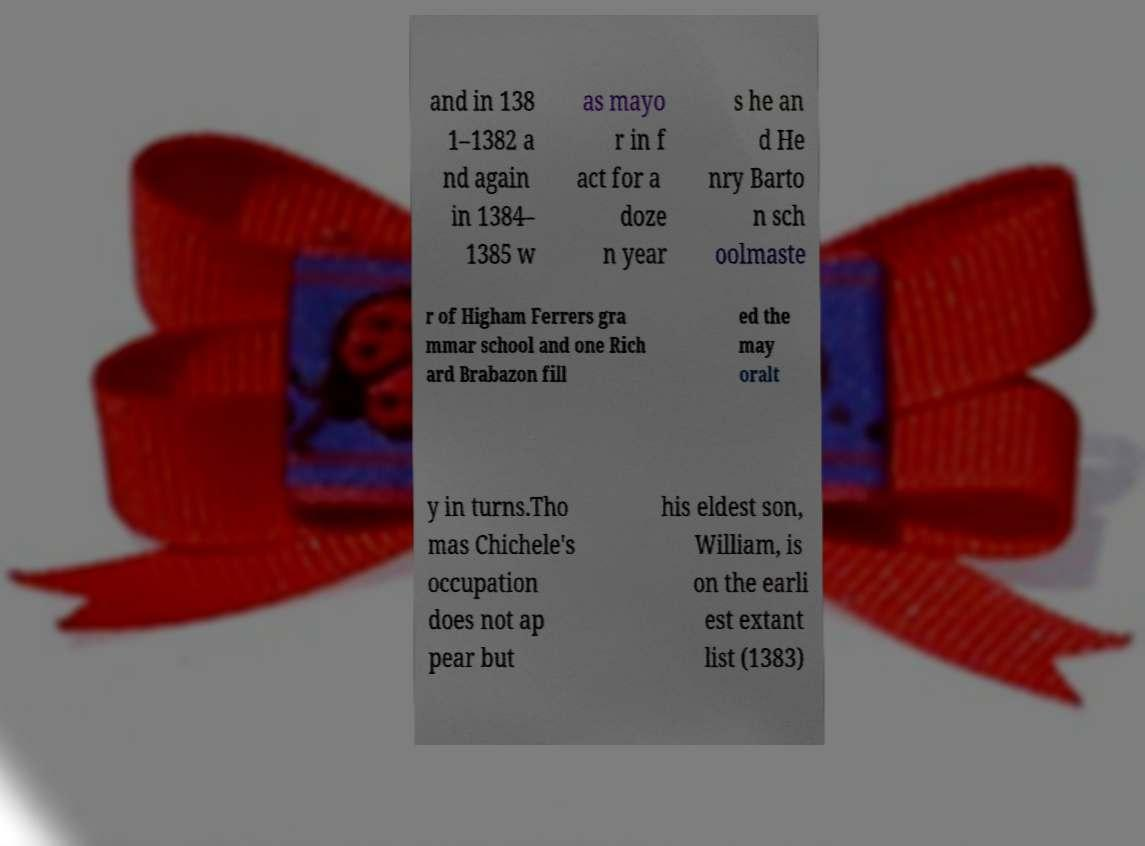Please read and relay the text visible in this image. What does it say? and in 138 1–1382 a nd again in 1384– 1385 w as mayo r in f act for a doze n year s he an d He nry Barto n sch oolmaste r of Higham Ferrers gra mmar school and one Rich ard Brabazon fill ed the may oralt y in turns.Tho mas Chichele's occupation does not ap pear but his eldest son, William, is on the earli est extant list (1383) 